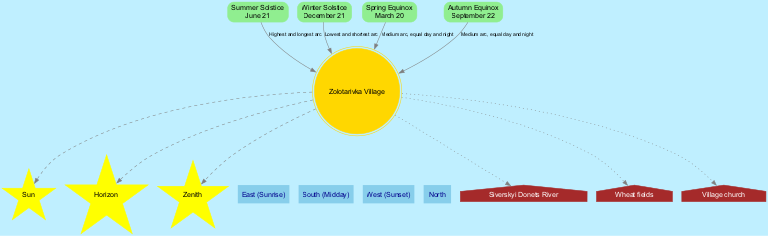What is the title of the diagram? The title is stated at the beginning of the diagram as "Sun's Path in Zolotarivka Sky."
Answer: Sun's Path in Zolotarivka Sky How many celestial elements are depicted in the diagram? The diagram lists three celestial elements: Sun, Horizon, and Zenith, which can be counted directly from the "celestial_elements" section.
Answer: 3 What is the date of the Summer Solstice? The Summer Solstice is associated with the date June 21, which is specified under the respective seasonal path.
Answer: June 21 Which seasonal path has the highest arc? The seasonal path labeled "Summer Solstice" states it has the "Highest and longest arc", making it the answer to the question.
Answer: Summer Solstice Which local landmark is represented as a house in the diagram? The diagram shows "Village church" as a local landmark depicted as a house, which is mentioned in the "local_landmarks" section.
Answer: Village church What cardinal direction is associated with Sunrise? The diagram indicates "East" as the cardinal direction where the Sun rises, which can be found in the "cardinal_directions" list.
Answer: East What is the path description for the Winter Solstice? The description provided for the Winter Solstice under "seasonal_paths" clearly states "Lowest and shortest arc."
Answer: Lowest and shortest arc On which date do day and night have equal duration? Both the Spring Equinox and Autumn Equinox, occurring on March 20 and September 22 respectively, are marked as having equal day and night; however, the question is about any date, so we can mention either.
Answer: March 20 What is the path description associated with the Autumn Equinox? The Autumn Equinox also states it has a "Medium arc, equal day and night," confirming its specific path description derived from the related seasonal paths section.
Answer: Medium arc, equal day and night 